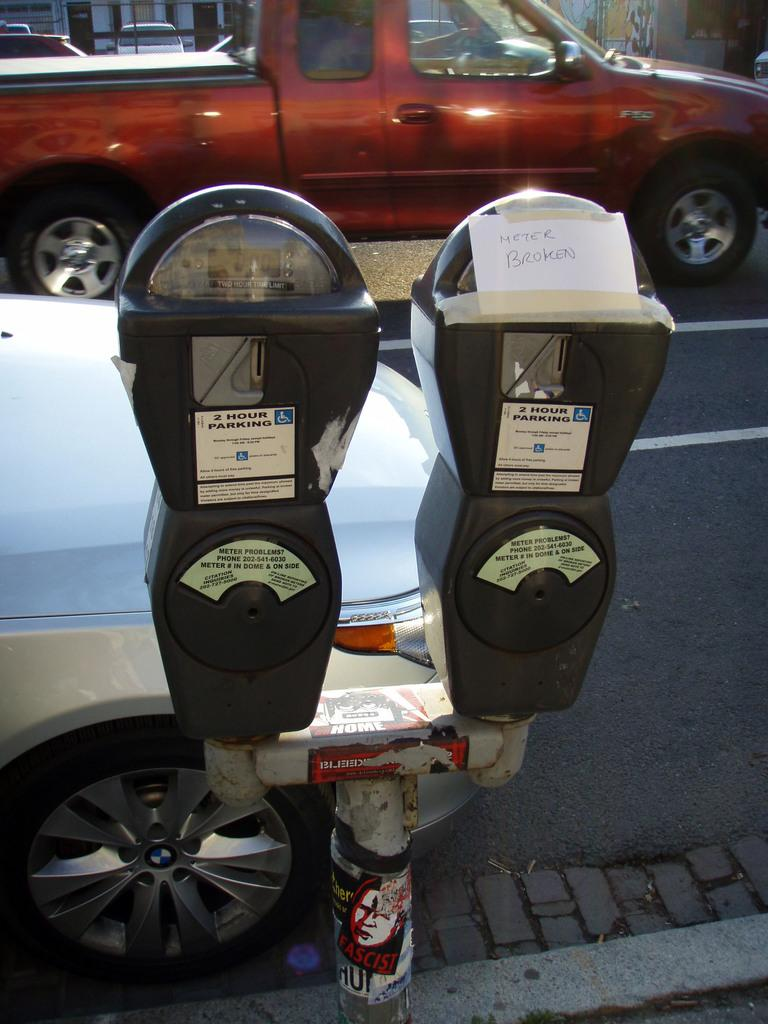<image>
Present a compact description of the photo's key features. A couple of parking meters on the side of the road with a paper taped to one meter with a note saying Meter Broken on it 